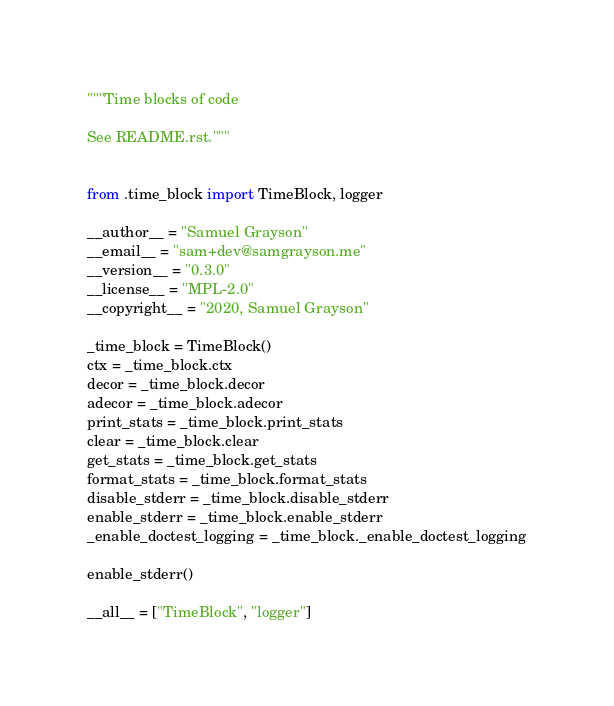<code> <loc_0><loc_0><loc_500><loc_500><_Python_>"""Time blocks of code

See README.rst."""


from .time_block import TimeBlock, logger

__author__ = "Samuel Grayson"
__email__ = "sam+dev@samgrayson.me"
__version__ = "0.3.0"
__license__ = "MPL-2.0"
__copyright__ = "2020, Samuel Grayson"

_time_block = TimeBlock()
ctx = _time_block.ctx
decor = _time_block.decor
adecor = _time_block.adecor
print_stats = _time_block.print_stats
clear = _time_block.clear
get_stats = _time_block.get_stats
format_stats = _time_block.format_stats
disable_stderr = _time_block.disable_stderr
enable_stderr = _time_block.enable_stderr
_enable_doctest_logging = _time_block._enable_doctest_logging

enable_stderr()

__all__ = ["TimeBlock", "logger"]
</code> 